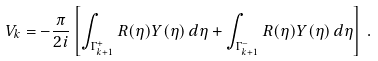<formula> <loc_0><loc_0><loc_500><loc_500>V _ { k } = - \frac { \pi } { 2 i } \left [ \int _ { \Gamma _ { k + 1 } ^ { + } } R ( \eta ) Y ( \eta ) \, d \eta + \int _ { \Gamma _ { k + 1 } ^ { - } } R ( \eta ) Y ( \eta ) \, d \eta \right ] \, .</formula> 